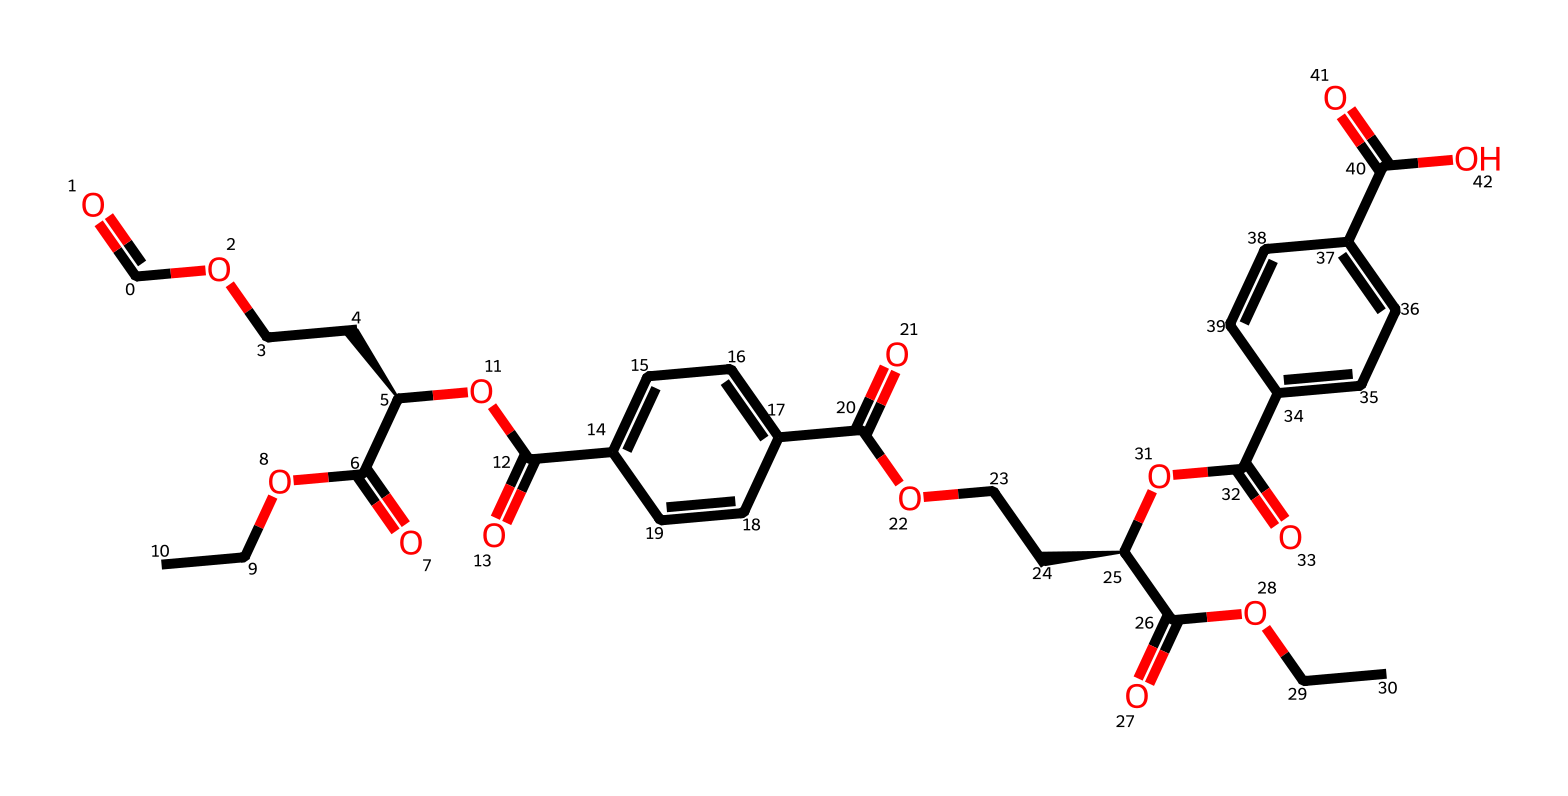What is the molecular formula of the synthetic polyester represented? Analyzing the SMILES structure, we can count the carbon (C), hydrogen (H), and oxygen (O) atoms present. The structure contains a total of 30 carbon atoms, 38 hydrogen atoms, and 10 oxygen atoms. Thus, the molecular formula can be written as C30H38O10.
Answer: C30H38O10 How many aromatic rings are present in the chemical structure? From the SMILES notation, we can identify two distinct cyclic structures representing aromatic rings (c1ccc(cc1) and c2ccc(cc2)). Therefore, there are 2 aromatic rings in total.
Answer: 2 What type of chemical reaction is typically used to synthesize polyesters like the one represented? Polyesters are commonly synthesized through a condensation reaction, specifically esterification, where a carboxylic acid reacts with an alcohol, eliminating water.
Answer: esterification Are there any functional groups present in this synthetic polyester? In examining the structure, we can identify carboxyl (-COOH) and ether (-O-) functional groups in the chains. Both are critical to the properties of polyesters.
Answer: carboxyl and ether What is the significance of the chiral center indicated in the structure? The notation [C@H] within the SMILES indicates a chiral carbon atom, meaning the compound can exist in different stereoisomeric forms. This can impact the properties and behavior of the polyester in textiles.
Answer: chiral carbon 